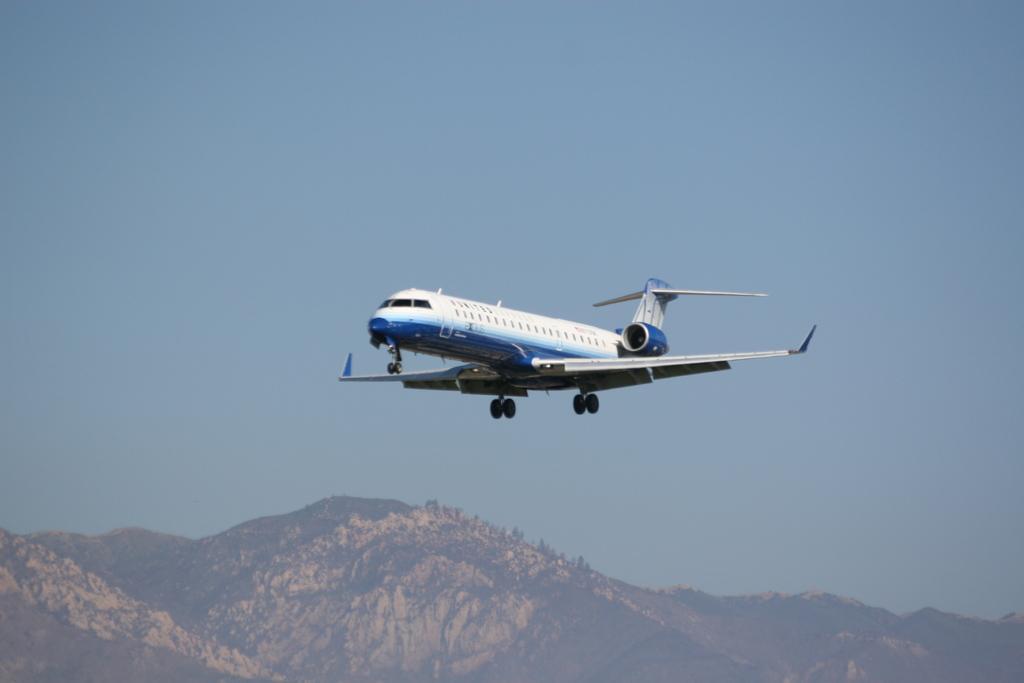Could you give a brief overview of what you see in this image? In this image I can see an aircraft which is white and blue in color is flying in the air. In the background I can see few mountains and the sky. 